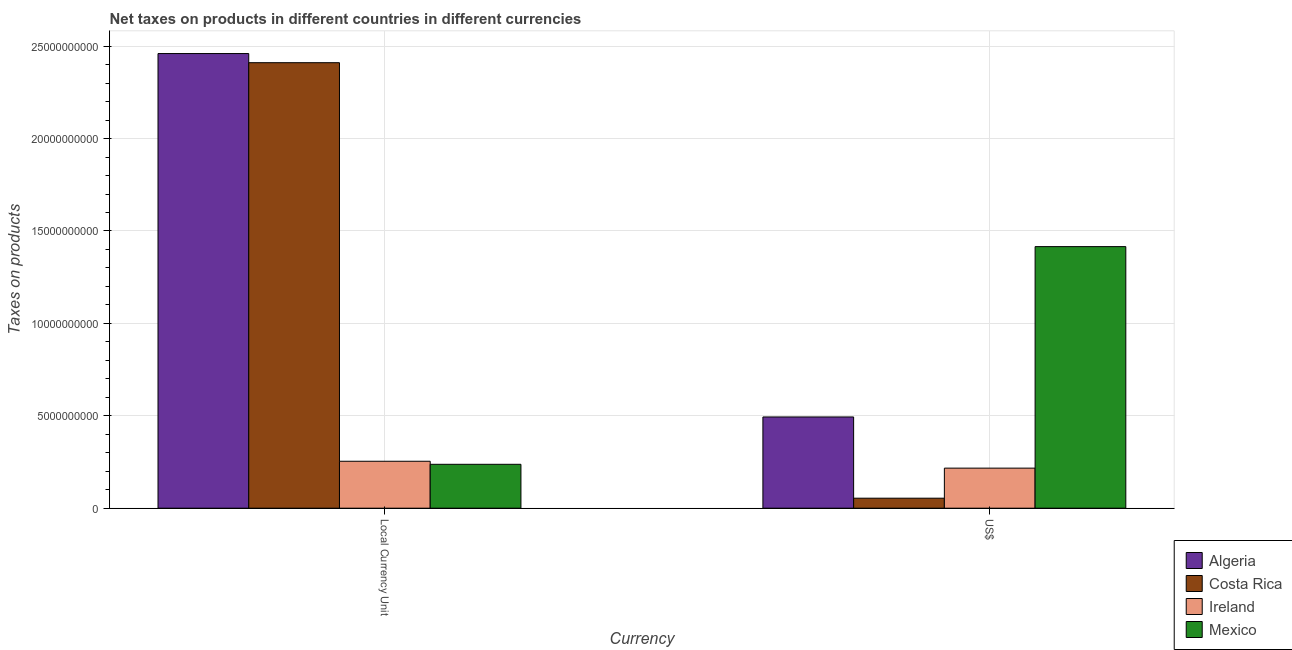How many groups of bars are there?
Provide a succinct answer. 2. How many bars are there on the 1st tick from the left?
Offer a very short reply. 4. How many bars are there on the 2nd tick from the right?
Give a very brief answer. 4. What is the label of the 1st group of bars from the left?
Make the answer very short. Local Currency Unit. What is the net taxes in us$ in Mexico?
Keep it short and to the point. 1.42e+1. Across all countries, what is the maximum net taxes in constant 2005 us$?
Ensure brevity in your answer.  2.46e+1. Across all countries, what is the minimum net taxes in constant 2005 us$?
Ensure brevity in your answer.  2.38e+09. What is the total net taxes in constant 2005 us$ in the graph?
Provide a succinct answer. 5.36e+1. What is the difference between the net taxes in constant 2005 us$ in Mexico and that in Costa Rica?
Provide a succinct answer. -2.17e+1. What is the difference between the net taxes in us$ in Algeria and the net taxes in constant 2005 us$ in Ireland?
Provide a short and direct response. 2.40e+09. What is the average net taxes in constant 2005 us$ per country?
Offer a terse response. 1.34e+1. What is the difference between the net taxes in us$ and net taxes in constant 2005 us$ in Algeria?
Your answer should be very brief. -1.97e+1. In how many countries, is the net taxes in us$ greater than 7000000000 units?
Give a very brief answer. 1. What is the ratio of the net taxes in constant 2005 us$ in Costa Rica to that in Algeria?
Offer a terse response. 0.98. Is the net taxes in constant 2005 us$ in Algeria less than that in Mexico?
Offer a terse response. No. What does the 3rd bar from the left in US$ represents?
Provide a short and direct response. Ireland. What does the 3rd bar from the right in Local Currency Unit represents?
Offer a terse response. Costa Rica. Are the values on the major ticks of Y-axis written in scientific E-notation?
Give a very brief answer. No. Does the graph contain grids?
Provide a short and direct response. Yes. What is the title of the graph?
Keep it short and to the point. Net taxes on products in different countries in different currencies. Does "Guinea-Bissau" appear as one of the legend labels in the graph?
Provide a succinct answer. No. What is the label or title of the X-axis?
Offer a very short reply. Currency. What is the label or title of the Y-axis?
Make the answer very short. Taxes on products. What is the Taxes on products in Algeria in Local Currency Unit?
Offer a very short reply. 2.46e+1. What is the Taxes on products in Costa Rica in Local Currency Unit?
Your answer should be very brief. 2.41e+1. What is the Taxes on products in Ireland in Local Currency Unit?
Ensure brevity in your answer.  2.54e+09. What is the Taxes on products of Mexico in Local Currency Unit?
Give a very brief answer. 2.38e+09. What is the Taxes on products of Algeria in US$?
Make the answer very short. 4.94e+09. What is the Taxes on products in Costa Rica in US$?
Offer a terse response. 5.41e+08. What is the Taxes on products in Ireland in US$?
Your answer should be very brief. 2.17e+09. What is the Taxes on products of Mexico in US$?
Give a very brief answer. 1.42e+1. Across all Currency, what is the maximum Taxes on products of Algeria?
Provide a short and direct response. 2.46e+1. Across all Currency, what is the maximum Taxes on products of Costa Rica?
Keep it short and to the point. 2.41e+1. Across all Currency, what is the maximum Taxes on products of Ireland?
Offer a terse response. 2.54e+09. Across all Currency, what is the maximum Taxes on products of Mexico?
Make the answer very short. 1.42e+1. Across all Currency, what is the minimum Taxes on products in Algeria?
Offer a terse response. 4.94e+09. Across all Currency, what is the minimum Taxes on products in Costa Rica?
Offer a terse response. 5.41e+08. Across all Currency, what is the minimum Taxes on products of Ireland?
Give a very brief answer. 2.17e+09. Across all Currency, what is the minimum Taxes on products in Mexico?
Provide a short and direct response. 2.38e+09. What is the total Taxes on products in Algeria in the graph?
Keep it short and to the point. 2.95e+1. What is the total Taxes on products of Costa Rica in the graph?
Provide a short and direct response. 2.46e+1. What is the total Taxes on products of Ireland in the graph?
Make the answer very short. 4.71e+09. What is the total Taxes on products in Mexico in the graph?
Provide a succinct answer. 1.65e+1. What is the difference between the Taxes on products of Algeria in Local Currency Unit and that in US$?
Keep it short and to the point. 1.97e+1. What is the difference between the Taxes on products of Costa Rica in Local Currency Unit and that in US$?
Your response must be concise. 2.36e+1. What is the difference between the Taxes on products in Ireland in Local Currency Unit and that in US$?
Make the answer very short. 3.72e+08. What is the difference between the Taxes on products of Mexico in Local Currency Unit and that in US$?
Your answer should be compact. -1.18e+1. What is the difference between the Taxes on products in Algeria in Local Currency Unit and the Taxes on products in Costa Rica in US$?
Your answer should be very brief. 2.41e+1. What is the difference between the Taxes on products of Algeria in Local Currency Unit and the Taxes on products of Ireland in US$?
Ensure brevity in your answer.  2.24e+1. What is the difference between the Taxes on products in Algeria in Local Currency Unit and the Taxes on products in Mexico in US$?
Provide a short and direct response. 1.04e+1. What is the difference between the Taxes on products in Costa Rica in Local Currency Unit and the Taxes on products in Ireland in US$?
Keep it short and to the point. 2.19e+1. What is the difference between the Taxes on products of Costa Rica in Local Currency Unit and the Taxes on products of Mexico in US$?
Offer a very short reply. 9.95e+09. What is the difference between the Taxes on products in Ireland in Local Currency Unit and the Taxes on products in Mexico in US$?
Offer a very short reply. -1.16e+1. What is the average Taxes on products in Algeria per Currency?
Offer a terse response. 1.48e+1. What is the average Taxes on products in Costa Rica per Currency?
Provide a short and direct response. 1.23e+1. What is the average Taxes on products in Ireland per Currency?
Ensure brevity in your answer.  2.35e+09. What is the average Taxes on products of Mexico per Currency?
Provide a short and direct response. 8.26e+09. What is the difference between the Taxes on products in Algeria and Taxes on products in Costa Rica in Local Currency Unit?
Give a very brief answer. 4.94e+08. What is the difference between the Taxes on products of Algeria and Taxes on products of Ireland in Local Currency Unit?
Your answer should be compact. 2.21e+1. What is the difference between the Taxes on products of Algeria and Taxes on products of Mexico in Local Currency Unit?
Ensure brevity in your answer.  2.22e+1. What is the difference between the Taxes on products of Costa Rica and Taxes on products of Ireland in Local Currency Unit?
Provide a short and direct response. 2.16e+1. What is the difference between the Taxes on products in Costa Rica and Taxes on products in Mexico in Local Currency Unit?
Make the answer very short. 2.17e+1. What is the difference between the Taxes on products in Ireland and Taxes on products in Mexico in Local Currency Unit?
Your answer should be very brief. 1.64e+08. What is the difference between the Taxes on products of Algeria and Taxes on products of Costa Rica in US$?
Your answer should be compact. 4.40e+09. What is the difference between the Taxes on products in Algeria and Taxes on products in Ireland in US$?
Make the answer very short. 2.77e+09. What is the difference between the Taxes on products in Algeria and Taxes on products in Mexico in US$?
Keep it short and to the point. -9.22e+09. What is the difference between the Taxes on products in Costa Rica and Taxes on products in Ireland in US$?
Provide a succinct answer. -1.63e+09. What is the difference between the Taxes on products of Costa Rica and Taxes on products of Mexico in US$?
Your answer should be very brief. -1.36e+1. What is the difference between the Taxes on products of Ireland and Taxes on products of Mexico in US$?
Your answer should be very brief. -1.20e+1. What is the ratio of the Taxes on products in Algeria in Local Currency Unit to that in US$?
Offer a very short reply. 4.98. What is the ratio of the Taxes on products in Costa Rica in Local Currency Unit to that in US$?
Your answer should be compact. 44.53. What is the ratio of the Taxes on products in Ireland in Local Currency Unit to that in US$?
Provide a short and direct response. 1.17. What is the ratio of the Taxes on products in Mexico in Local Currency Unit to that in US$?
Offer a very short reply. 0.17. What is the difference between the highest and the second highest Taxes on products in Algeria?
Your answer should be compact. 1.97e+1. What is the difference between the highest and the second highest Taxes on products in Costa Rica?
Offer a very short reply. 2.36e+1. What is the difference between the highest and the second highest Taxes on products in Ireland?
Give a very brief answer. 3.72e+08. What is the difference between the highest and the second highest Taxes on products in Mexico?
Offer a terse response. 1.18e+1. What is the difference between the highest and the lowest Taxes on products in Algeria?
Your answer should be compact. 1.97e+1. What is the difference between the highest and the lowest Taxes on products of Costa Rica?
Give a very brief answer. 2.36e+1. What is the difference between the highest and the lowest Taxes on products in Ireland?
Your answer should be compact. 3.72e+08. What is the difference between the highest and the lowest Taxes on products in Mexico?
Make the answer very short. 1.18e+1. 